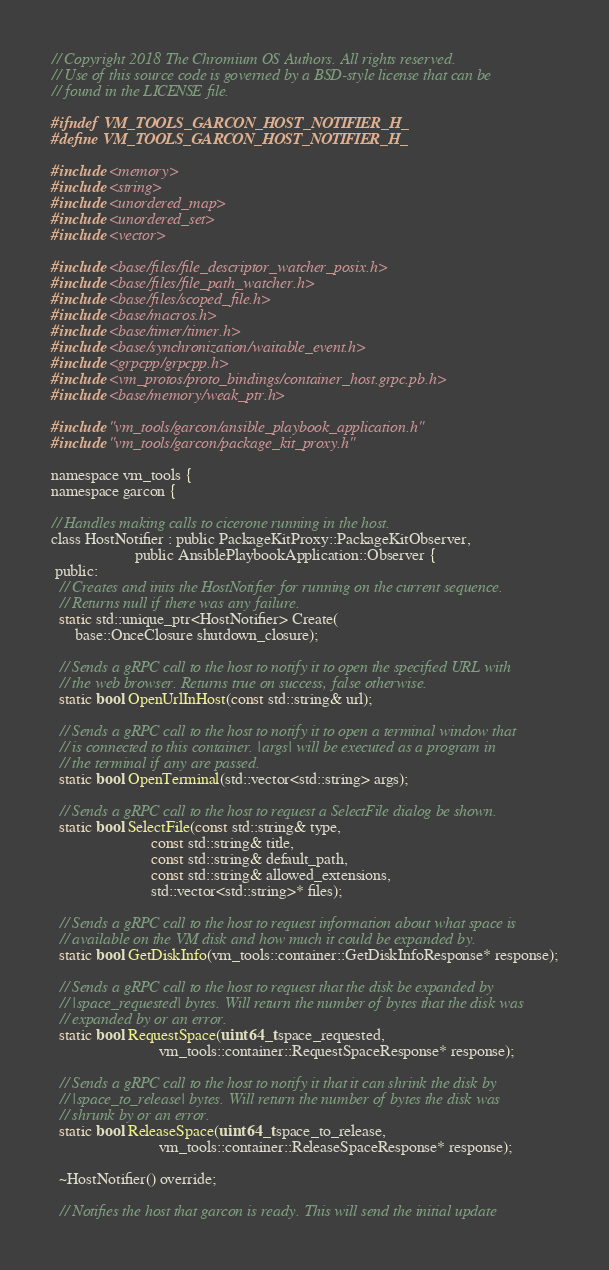Convert code to text. <code><loc_0><loc_0><loc_500><loc_500><_C_>// Copyright 2018 The Chromium OS Authors. All rights reserved.
// Use of this source code is governed by a BSD-style license that can be
// found in the LICENSE file.

#ifndef VM_TOOLS_GARCON_HOST_NOTIFIER_H_
#define VM_TOOLS_GARCON_HOST_NOTIFIER_H_

#include <memory>
#include <string>
#include <unordered_map>
#include <unordered_set>
#include <vector>

#include <base/files/file_descriptor_watcher_posix.h>
#include <base/files/file_path_watcher.h>
#include <base/files/scoped_file.h>
#include <base/macros.h>
#include <base/timer/timer.h>
#include <base/synchronization/waitable_event.h>
#include <grpcpp/grpcpp.h>
#include <vm_protos/proto_bindings/container_host.grpc.pb.h>
#include <base/memory/weak_ptr.h>

#include "vm_tools/garcon/ansible_playbook_application.h"
#include "vm_tools/garcon/package_kit_proxy.h"

namespace vm_tools {
namespace garcon {

// Handles making calls to cicerone running in the host.
class HostNotifier : public PackageKitProxy::PackageKitObserver,
                     public AnsiblePlaybookApplication::Observer {
 public:
  // Creates and inits the HostNotifier for running on the current sequence.
  // Returns null if there was any failure.
  static std::unique_ptr<HostNotifier> Create(
      base::OnceClosure shutdown_closure);

  // Sends a gRPC call to the host to notify it to open the specified URL with
  // the web browser. Returns true on success, false otherwise.
  static bool OpenUrlInHost(const std::string& url);

  // Sends a gRPC call to the host to notify it to open a terminal window that
  // is connected to this container. |args| will be executed as a program in
  // the terminal if any are passed.
  static bool OpenTerminal(std::vector<std::string> args);

  // Sends a gRPC call to the host to request a SelectFile dialog be shown.
  static bool SelectFile(const std::string& type,
                         const std::string& title,
                         const std::string& default_path,
                         const std::string& allowed_extensions,
                         std::vector<std::string>* files);

  // Sends a gRPC call to the host to request information about what space is
  // available on the VM disk and how much it could be expanded by.
  static bool GetDiskInfo(vm_tools::container::GetDiskInfoResponse* response);

  // Sends a gRPC call to the host to request that the disk be expanded by
  // |space_requested| bytes. Will return the number of bytes that the disk was
  // expanded by or an error.
  static bool RequestSpace(uint64_t space_requested,
                           vm_tools::container::RequestSpaceResponse* response);

  // Sends a gRPC call to the host to notify it that it can shrink the disk by
  // |space_to_release| bytes. Will return the number of bytes the disk was
  // shrunk by or an error.
  static bool ReleaseSpace(uint64_t space_to_release,
                           vm_tools::container::ReleaseSpaceResponse* response);

  ~HostNotifier() override;

  // Notifies the host that garcon is ready. This will send the initial update</code> 